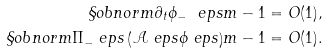Convert formula to latex. <formula><loc_0><loc_0><loc_500><loc_500>\S o b n o r m { \partial _ { t } \phi _ { - } \ e p s } { m - 1 } = O ( 1 ) , \\ \S o b n o r m { \Pi _ { - } \ e p s \left ( \mathcal { A } \ e p s \phi \ e p s \right ) } { m - 1 } = O ( 1 ) .</formula> 